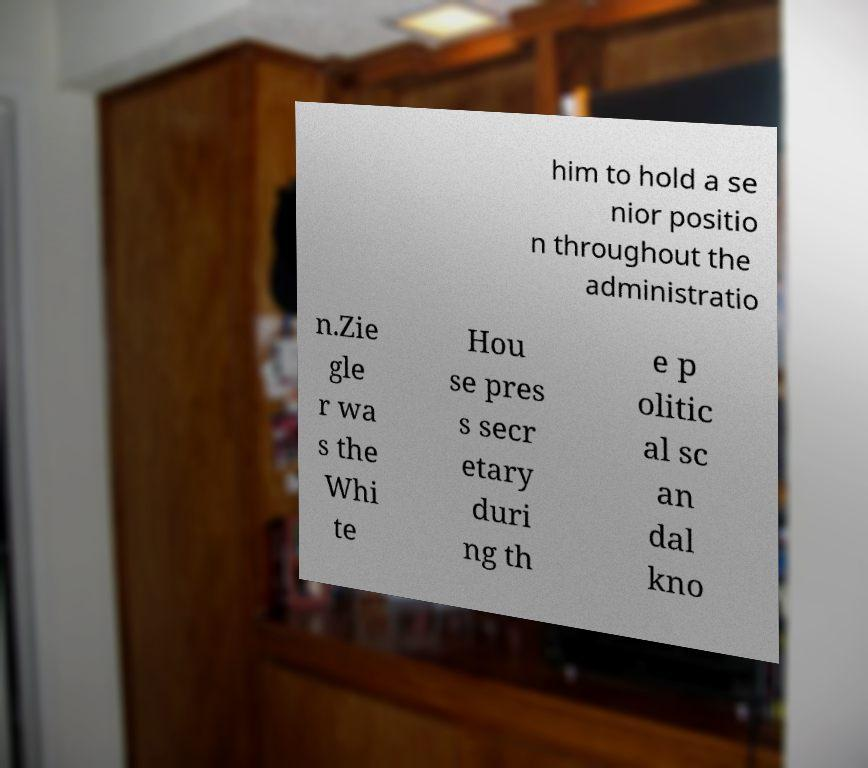There's text embedded in this image that I need extracted. Can you transcribe it verbatim? him to hold a se nior positio n throughout the administratio n.Zie gle r wa s the Whi te Hou se pres s secr etary duri ng th e p olitic al sc an dal kno 